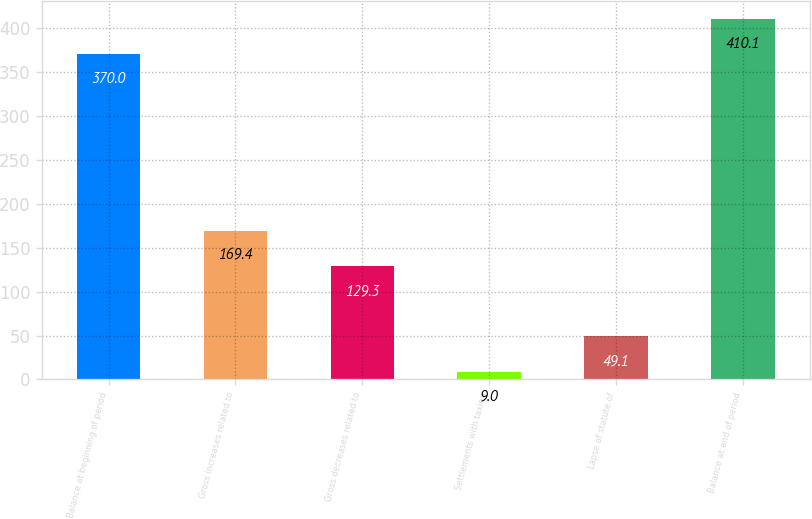Convert chart. <chart><loc_0><loc_0><loc_500><loc_500><bar_chart><fcel>Balance at beginning of period<fcel>Gross increases related to<fcel>Gross decreases related to<fcel>Settlements with taxing<fcel>Lapse of statute of<fcel>Balance at end of period<nl><fcel>370<fcel>169.4<fcel>129.3<fcel>9<fcel>49.1<fcel>410.1<nl></chart> 